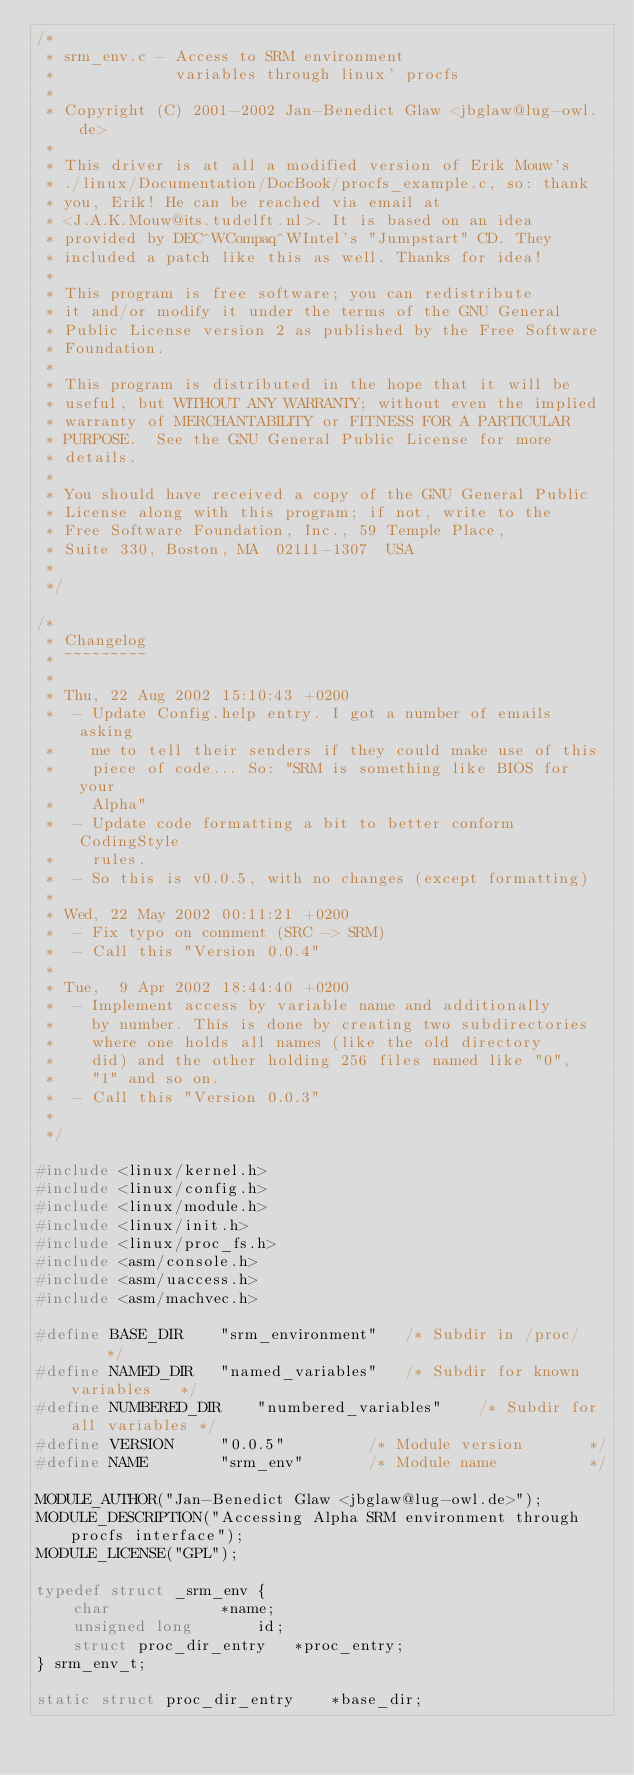Convert code to text. <code><loc_0><loc_0><loc_500><loc_500><_C_>/*
 * srm_env.c - Access to SRM environment
 *             variables through linux' procfs
 *
 * Copyright (C) 2001-2002 Jan-Benedict Glaw <jbglaw@lug-owl.de>
 *
 * This driver is at all a modified version of Erik Mouw's
 * ./linux/Documentation/DocBook/procfs_example.c, so: thank
 * you, Erik! He can be reached via email at
 * <J.A.K.Mouw@its.tudelft.nl>. It is based on an idea
 * provided by DEC^WCompaq^WIntel's "Jumpstart" CD. They
 * included a patch like this as well. Thanks for idea!
 *
 * This program is free software; you can redistribute
 * it and/or modify it under the terms of the GNU General
 * Public License version 2 as published by the Free Software
 * Foundation.
 *
 * This program is distributed in the hope that it will be
 * useful, but WITHOUT ANY WARRANTY; without even the implied
 * warranty of MERCHANTABILITY or FITNESS FOR A PARTICULAR
 * PURPOSE.  See the GNU General Public License for more
 * details.
 * 
 * You should have received a copy of the GNU General Public
 * License along with this program; if not, write to the
 * Free Software Foundation, Inc., 59 Temple Place,
 * Suite 330, Boston, MA  02111-1307  USA
 *
 */

/*
 * Changelog
 * ~~~~~~~~~
 *
 * Thu, 22 Aug 2002 15:10:43 +0200
 * 	- Update Config.help entry. I got a number of emails asking
 * 	  me to tell their senders if they could make use of this
 * 	  piece of code... So: "SRM is something like BIOS for your
 * 	  Alpha"
 * 	- Update code formatting a bit to better conform CodingStyle
 * 	  rules.
 * 	- So this is v0.0.5, with no changes (except formatting)
 * 	
 * Wed, 22 May 2002 00:11:21 +0200
 * 	- Fix typo on comment (SRC -> SRM)
 * 	- Call this "Version 0.0.4"
 *
 * Tue,  9 Apr 2002 18:44:40 +0200
 * 	- Implement access by variable name and additionally
 * 	  by number. This is done by creating two subdirectories
 * 	  where one holds all names (like the old directory
 * 	  did) and the other holding 256 files named like "0",
 * 	  "1" and so on.
 * 	- Call this "Version 0.0.3"
 *
 */

#include <linux/kernel.h>
#include <linux/config.h>
#include <linux/module.h>
#include <linux/init.h>
#include <linux/proc_fs.h>
#include <asm/console.h>
#include <asm/uaccess.h>
#include <asm/machvec.h>

#define BASE_DIR	"srm_environment"	/* Subdir in /proc/		*/
#define NAMED_DIR	"named_variables"	/* Subdir for known variables	*/
#define NUMBERED_DIR	"numbered_variables"	/* Subdir for all variables	*/
#define VERSION		"0.0.5"			/* Module version		*/
#define NAME		"srm_env"		/* Module name			*/

MODULE_AUTHOR("Jan-Benedict Glaw <jbglaw@lug-owl.de>");
MODULE_DESCRIPTION("Accessing Alpha SRM environment through procfs interface");
MODULE_LICENSE("GPL");

typedef struct _srm_env {
	char			*name;
	unsigned long		id;
	struct proc_dir_entry	*proc_entry;
} srm_env_t;

static struct proc_dir_entry	*base_dir;</code> 